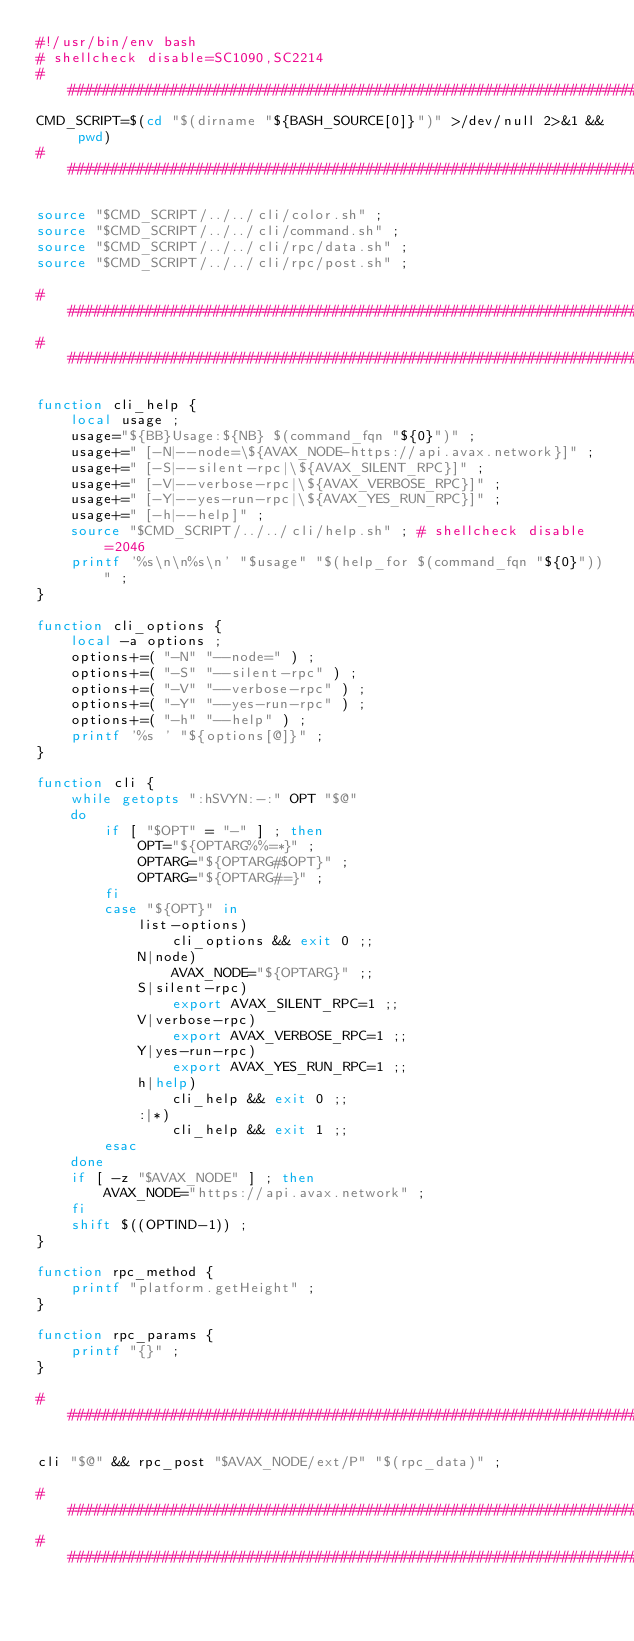Convert code to text. <code><loc_0><loc_0><loc_500><loc_500><_Bash_>#!/usr/bin/env bash
# shellcheck disable=SC1090,SC2214
###############################################################################
CMD_SCRIPT=$(cd "$(dirname "${BASH_SOURCE[0]}")" >/dev/null 2>&1 && pwd)
###############################################################################

source "$CMD_SCRIPT/../../cli/color.sh" ;
source "$CMD_SCRIPT/../../cli/command.sh" ;
source "$CMD_SCRIPT/../../cli/rpc/data.sh" ;
source "$CMD_SCRIPT/../../cli/rpc/post.sh" ;

###############################################################################
###############################################################################

function cli_help {
    local usage ;
    usage="${BB}Usage:${NB} $(command_fqn "${0}")" ;
    usage+=" [-N|--node=\${AVAX_NODE-https://api.avax.network}]" ;
    usage+=" [-S|--silent-rpc|\${AVAX_SILENT_RPC}]" ;
    usage+=" [-V|--verbose-rpc|\${AVAX_VERBOSE_RPC}]" ;
    usage+=" [-Y|--yes-run-rpc|\${AVAX_YES_RUN_RPC}]" ;
    usage+=" [-h|--help]" ;
    source "$CMD_SCRIPT/../../cli/help.sh" ; # shellcheck disable=2046
    printf '%s\n\n%s\n' "$usage" "$(help_for $(command_fqn "${0}"))" ;
}

function cli_options {
    local -a options ;
    options+=( "-N" "--node=" ) ;
    options+=( "-S" "--silent-rpc" ) ;
    options+=( "-V" "--verbose-rpc" ) ;
    options+=( "-Y" "--yes-run-rpc" ) ;
    options+=( "-h" "--help" ) ;
    printf '%s ' "${options[@]}" ;
}

function cli {
    while getopts ":hSVYN:-:" OPT "$@"
    do
        if [ "$OPT" = "-" ] ; then
            OPT="${OPTARG%%=*}" ;
            OPTARG="${OPTARG#$OPT}" ;
            OPTARG="${OPTARG#=}" ;
        fi
        case "${OPT}" in
            list-options)
                cli_options && exit 0 ;;
            N|node)
                AVAX_NODE="${OPTARG}" ;;
            S|silent-rpc)
                export AVAX_SILENT_RPC=1 ;;
            V|verbose-rpc)
                export AVAX_VERBOSE_RPC=1 ;;
            Y|yes-run-rpc)
                export AVAX_YES_RUN_RPC=1 ;;
            h|help)
                cli_help && exit 0 ;;
            :|*)
                cli_help && exit 1 ;;
        esac
    done
    if [ -z "$AVAX_NODE" ] ; then
        AVAX_NODE="https://api.avax.network" ;
    fi
    shift $((OPTIND-1)) ;
}

function rpc_method {
    printf "platform.getHeight" ;
}

function rpc_params {
    printf "{}" ;
}

###############################################################################

cli "$@" && rpc_post "$AVAX_NODE/ext/P" "$(rpc_data)" ;

###############################################################################
###############################################################################
</code> 